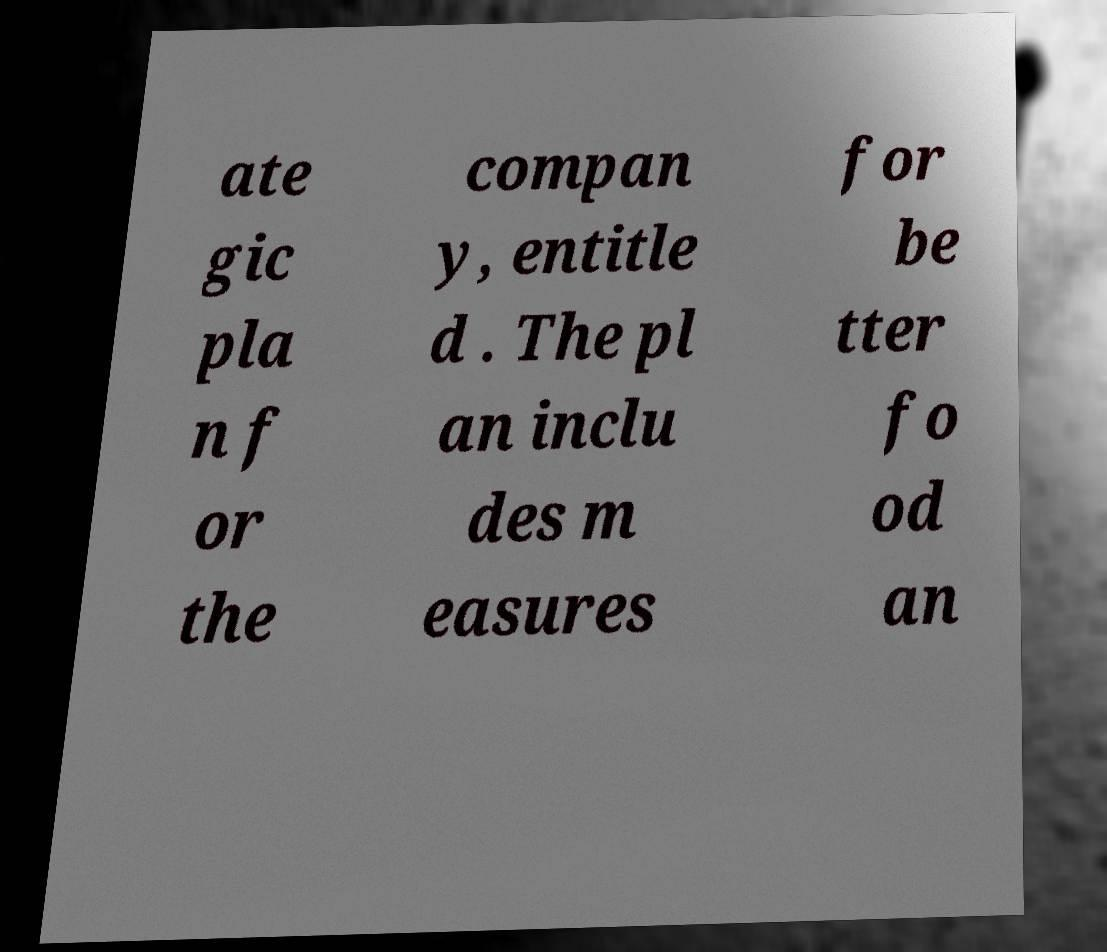Please identify and transcribe the text found in this image. ate gic pla n f or the compan y, entitle d . The pl an inclu des m easures for be tter fo od an 